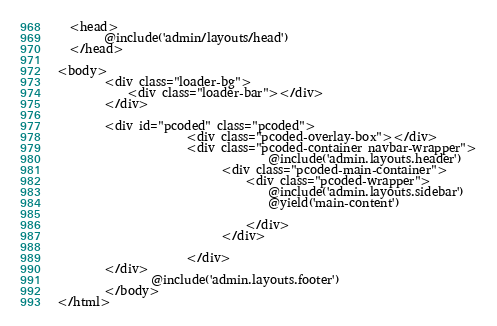Convert code to text. <code><loc_0><loc_0><loc_500><loc_500><_PHP_>  <head>
        @include('admin/layouts/head')
  </head>
         
<body>
        <div class="loader-bg">
            <div class="loader-bar"></div>
        </div>

        <div id="pcoded" class="pcoded">
                      <div class="pcoded-overlay-box"></div>
                      <div class="pcoded-container navbar-wrapper">
                                    @include('admin.layouts.header')
                            <div class="pcoded-main-container">
                                <div class="pcoded-wrapper">
                                    @include('admin.layouts.sidebar')
                                    @yield('main-content')

                                </div>
                            </div>
                           
                      </div>
        </div>
                @include('admin.layouts.footer')
        </body>
</html></code> 